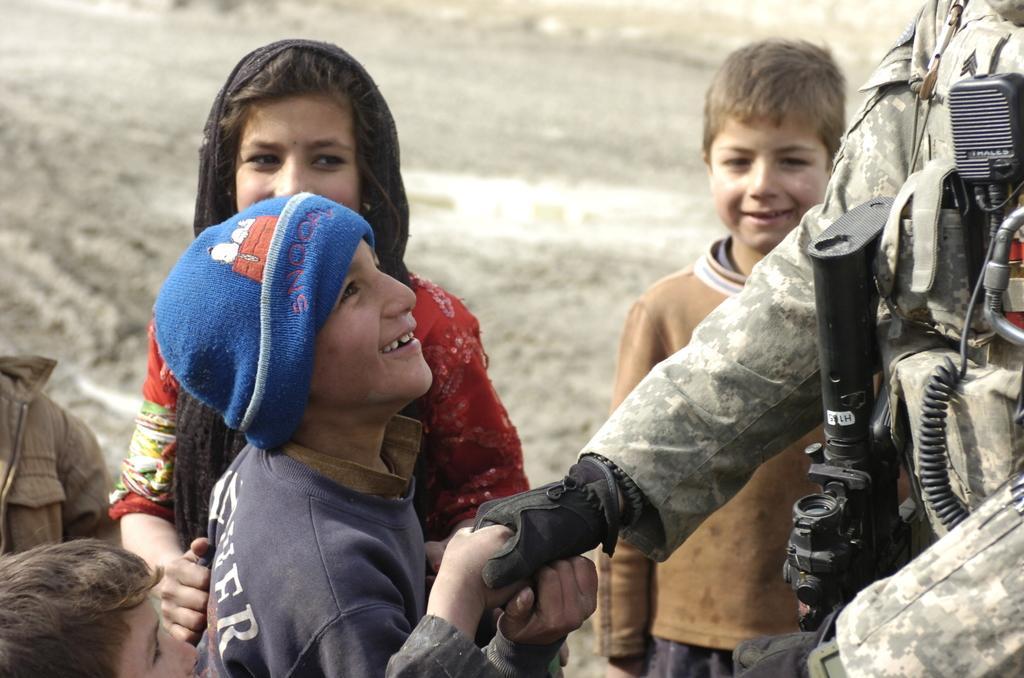In one or two sentences, can you explain what this image depicts? In this image we can see people standing on the ground. 